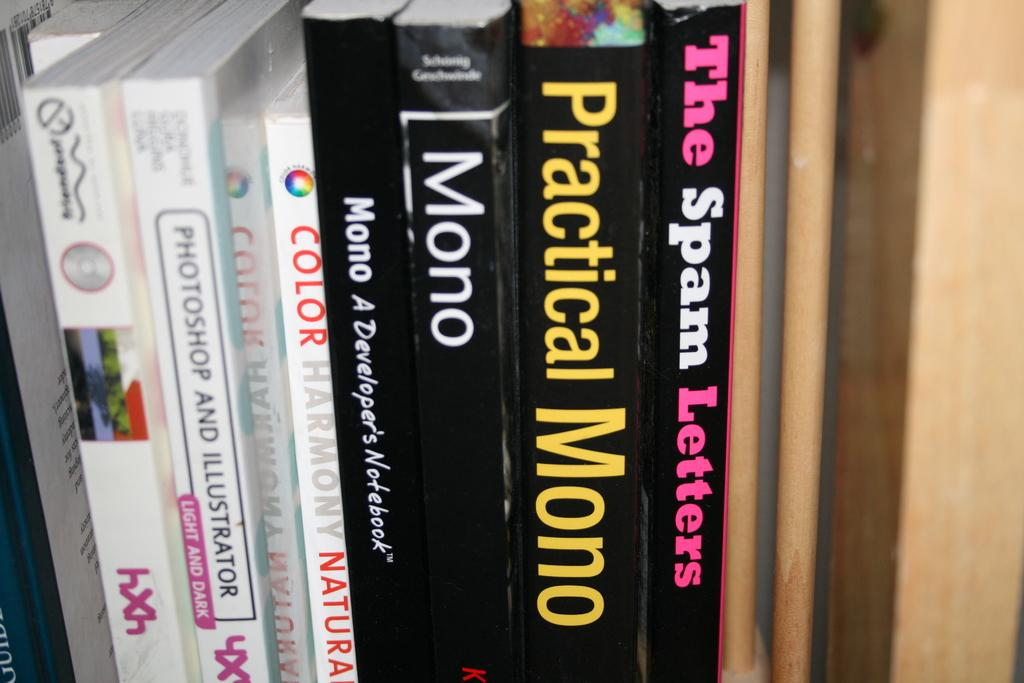<image>
Provide a brief description of the given image. Stack of books about various topics including mono on a shelf. 